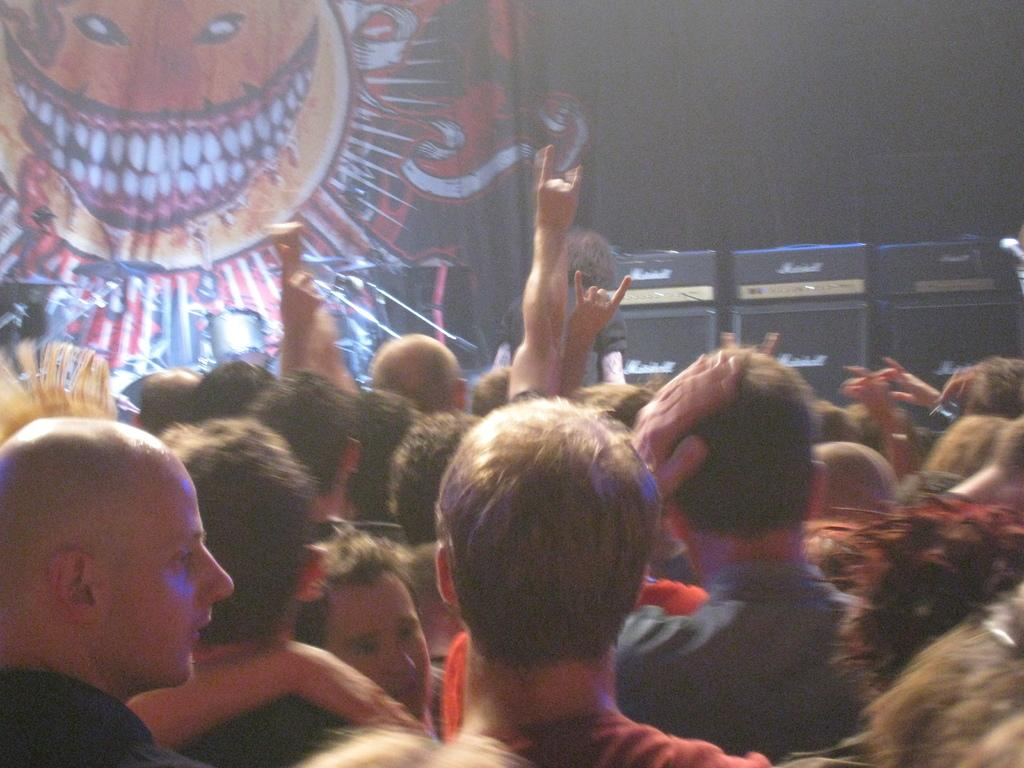What are the people in the image doing? The people in the image are standing. What musical instruments are visible in the image? There are drums in the image. Where are the drums located? The drums are on the stage in the image. What can be seen in the background of the image? There is a cloth in the background of the image. What equipment is present on the right side of the image? There are speakers on the right side of the image. How many credits can be seen on the light in the image? There is no light present in the image, and therefore no credits can be seen on it. 